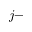<formula> <loc_0><loc_0><loc_500><loc_500>j -</formula> 